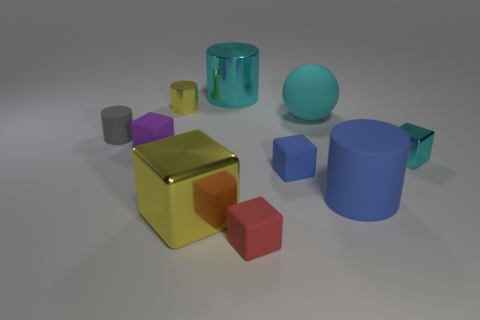How many large objects are yellow cylinders or blue things?
Your response must be concise. 1. Are there fewer cyan shiny cylinders in front of the large block than cylinders that are to the left of the red cube?
Your response must be concise. Yes. How many objects are either cyan rubber balls or blue blocks?
Provide a succinct answer. 2. How many balls are in front of the gray cylinder?
Make the answer very short. 0. Is the tiny shiny cube the same color as the matte sphere?
Your answer should be compact. Yes. What shape is the big thing that is made of the same material as the big sphere?
Give a very brief answer. Cylinder. Is the shape of the small gray object behind the large yellow cube the same as  the big cyan rubber thing?
Provide a short and direct response. No. How many cyan things are either large objects or shiny blocks?
Ensure brevity in your answer.  3. Are there the same number of tiny metal objects behind the big metallic block and big blocks right of the large blue cylinder?
Ensure brevity in your answer.  No. There is a rubber cylinder right of the rubber cylinder left of the large cylinder that is on the left side of the big matte cylinder; what is its color?
Provide a short and direct response. Blue. 